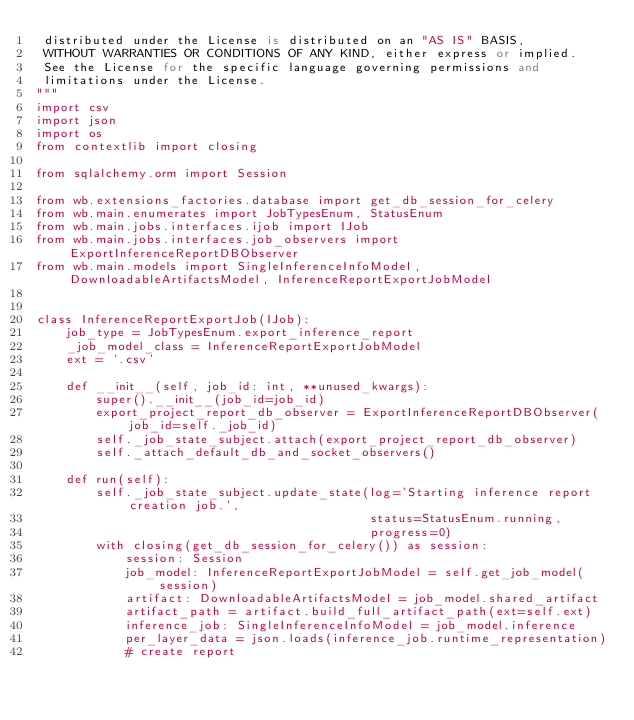Convert code to text. <code><loc_0><loc_0><loc_500><loc_500><_Python_> distributed under the License is distributed on an "AS IS" BASIS,
 WITHOUT WARRANTIES OR CONDITIONS OF ANY KIND, either express or implied.
 See the License for the specific language governing permissions and
 limitations under the License.
"""
import csv
import json
import os
from contextlib import closing

from sqlalchemy.orm import Session

from wb.extensions_factories.database import get_db_session_for_celery
from wb.main.enumerates import JobTypesEnum, StatusEnum
from wb.main.jobs.interfaces.ijob import IJob
from wb.main.jobs.interfaces.job_observers import ExportInferenceReportDBObserver
from wb.main.models import SingleInferenceInfoModel, DownloadableArtifactsModel, InferenceReportExportJobModel


class InferenceReportExportJob(IJob):
    job_type = JobTypesEnum.export_inference_report
    _job_model_class = InferenceReportExportJobModel
    ext = '.csv'

    def __init__(self, job_id: int, **unused_kwargs):
        super().__init__(job_id=job_id)
        export_project_report_db_observer = ExportInferenceReportDBObserver(job_id=self._job_id)
        self._job_state_subject.attach(export_project_report_db_observer)
        self._attach_default_db_and_socket_observers()

    def run(self):
        self._job_state_subject.update_state(log='Starting inference report creation job.',
                                             status=StatusEnum.running,
                                             progress=0)
        with closing(get_db_session_for_celery()) as session:
            session: Session
            job_model: InferenceReportExportJobModel = self.get_job_model(session)
            artifact: DownloadableArtifactsModel = job_model.shared_artifact
            artifact_path = artifact.build_full_artifact_path(ext=self.ext)
            inference_job: SingleInferenceInfoModel = job_model.inference
            per_layer_data = json.loads(inference_job.runtime_representation)
            # create report</code> 